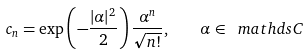<formula> <loc_0><loc_0><loc_500><loc_500>c _ { n } = \exp \left ( - \frac { | \alpha | ^ { 2 } } { 2 } \right ) \frac { \alpha ^ { n } } { \sqrt { n ! } } , \quad \alpha \in \ m a t h d s { C }</formula> 